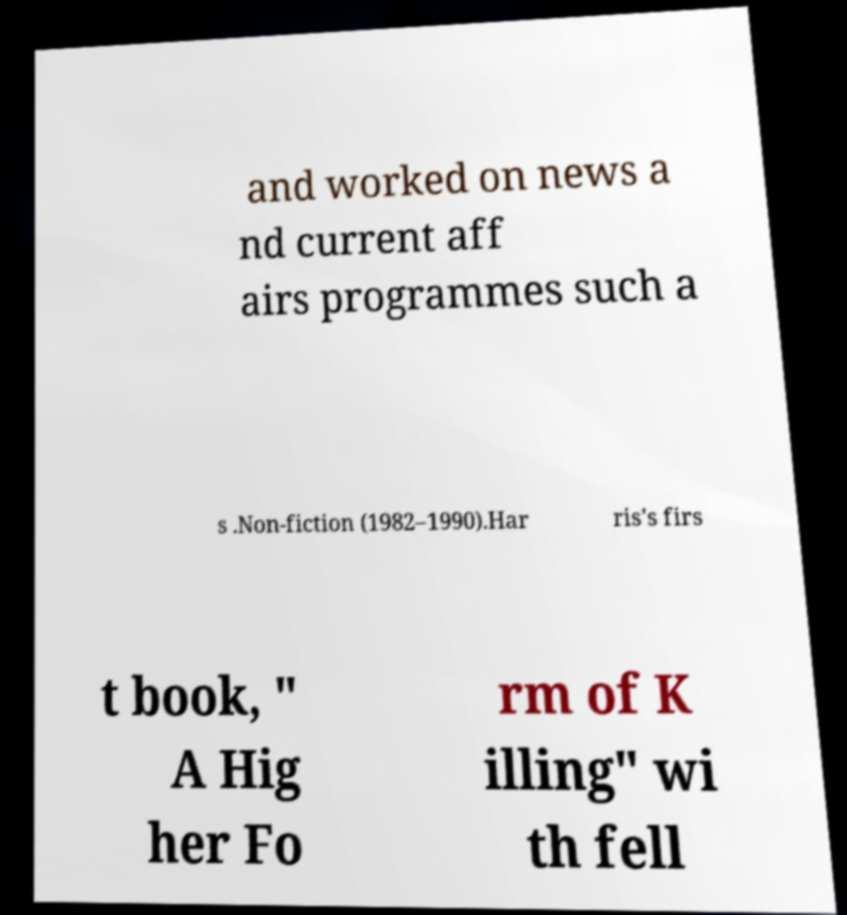Could you extract and type out the text from this image? and worked on news a nd current aff airs programmes such a s .Non-fiction (1982–1990).Har ris's firs t book, " A Hig her Fo rm of K illing" wi th fell 